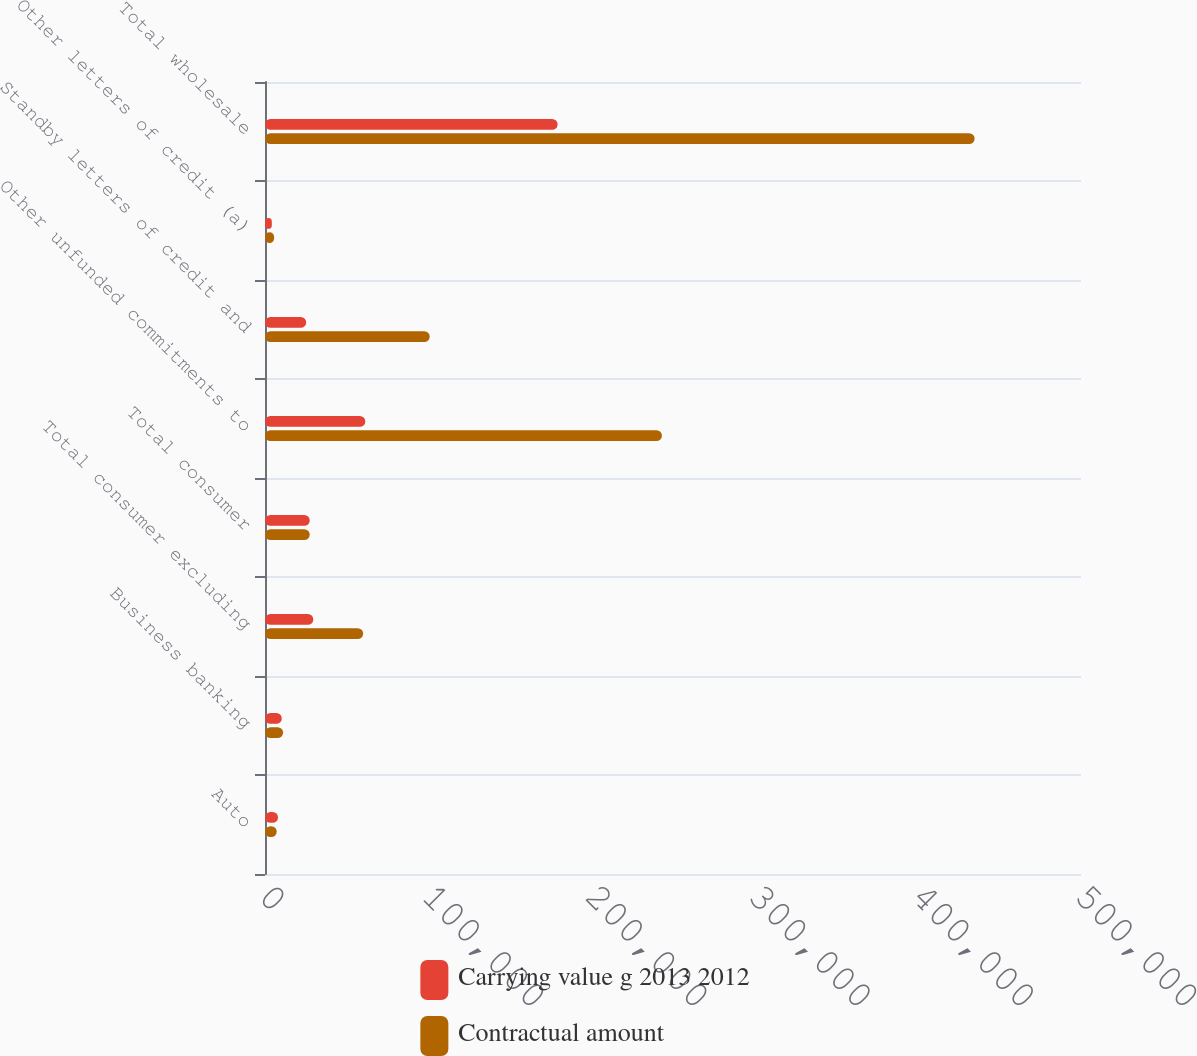Convert chart to OTSL. <chart><loc_0><loc_0><loc_500><loc_500><stacked_bar_chart><ecel><fcel>Auto<fcel>Business banking<fcel>Total consumer excluding<fcel>Total consumer<fcel>Other unfunded commitments to<fcel>Standby letters of credit and<fcel>Other letters of credit (a)<fcel>Total wholesale<nl><fcel>Carrying value g 2013 2012<fcel>7992<fcel>10282<fcel>29588<fcel>27405.5<fcel>61459<fcel>25223<fcel>4176<fcel>179301<nl><fcel>Contractual amount<fcel>7185<fcel>11092<fcel>60156<fcel>27405.5<fcel>243225<fcel>100929<fcel>5573<fcel>434814<nl></chart> 